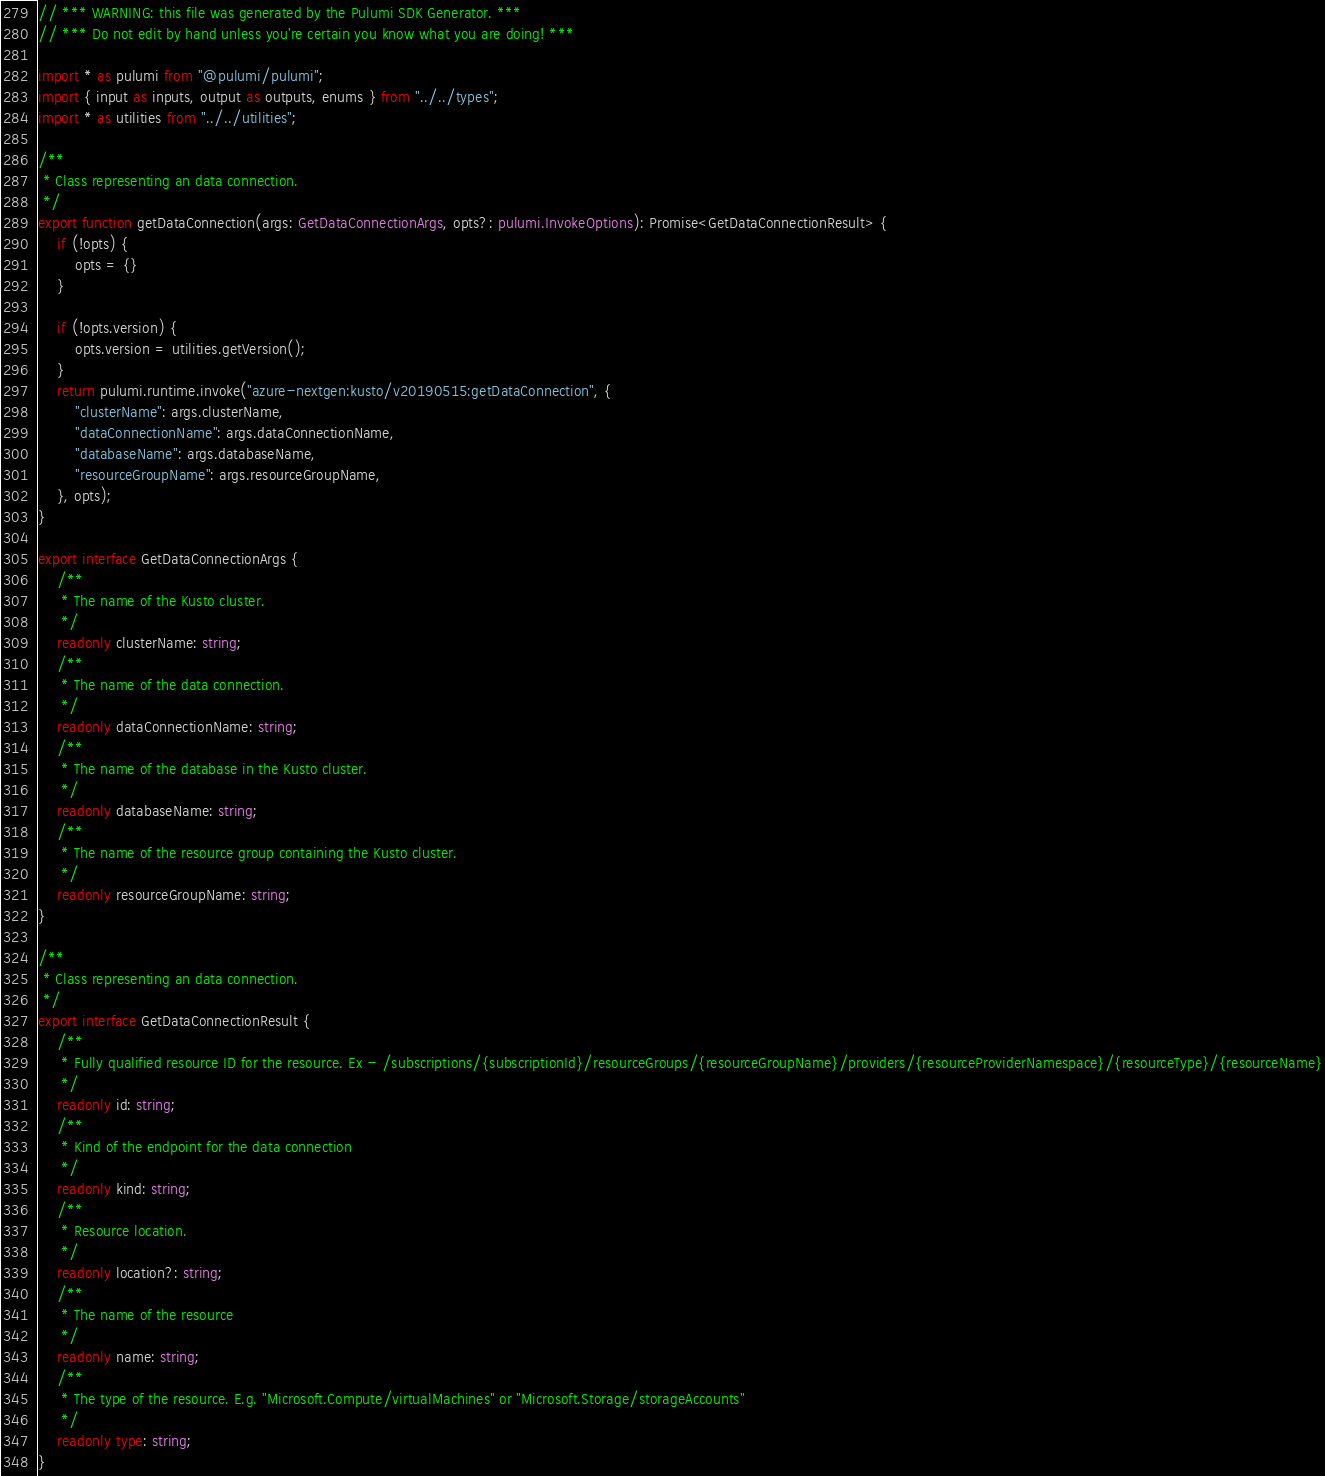<code> <loc_0><loc_0><loc_500><loc_500><_TypeScript_>// *** WARNING: this file was generated by the Pulumi SDK Generator. ***
// *** Do not edit by hand unless you're certain you know what you are doing! ***

import * as pulumi from "@pulumi/pulumi";
import { input as inputs, output as outputs, enums } from "../../types";
import * as utilities from "../../utilities";

/**
 * Class representing an data connection.
 */
export function getDataConnection(args: GetDataConnectionArgs, opts?: pulumi.InvokeOptions): Promise<GetDataConnectionResult> {
    if (!opts) {
        opts = {}
    }

    if (!opts.version) {
        opts.version = utilities.getVersion();
    }
    return pulumi.runtime.invoke("azure-nextgen:kusto/v20190515:getDataConnection", {
        "clusterName": args.clusterName,
        "dataConnectionName": args.dataConnectionName,
        "databaseName": args.databaseName,
        "resourceGroupName": args.resourceGroupName,
    }, opts);
}

export interface GetDataConnectionArgs {
    /**
     * The name of the Kusto cluster.
     */
    readonly clusterName: string;
    /**
     * The name of the data connection.
     */
    readonly dataConnectionName: string;
    /**
     * The name of the database in the Kusto cluster.
     */
    readonly databaseName: string;
    /**
     * The name of the resource group containing the Kusto cluster.
     */
    readonly resourceGroupName: string;
}

/**
 * Class representing an data connection.
 */
export interface GetDataConnectionResult {
    /**
     * Fully qualified resource ID for the resource. Ex - /subscriptions/{subscriptionId}/resourceGroups/{resourceGroupName}/providers/{resourceProviderNamespace}/{resourceType}/{resourceName}
     */
    readonly id: string;
    /**
     * Kind of the endpoint for the data connection
     */
    readonly kind: string;
    /**
     * Resource location.
     */
    readonly location?: string;
    /**
     * The name of the resource
     */
    readonly name: string;
    /**
     * The type of the resource. E.g. "Microsoft.Compute/virtualMachines" or "Microsoft.Storage/storageAccounts"
     */
    readonly type: string;
}
</code> 